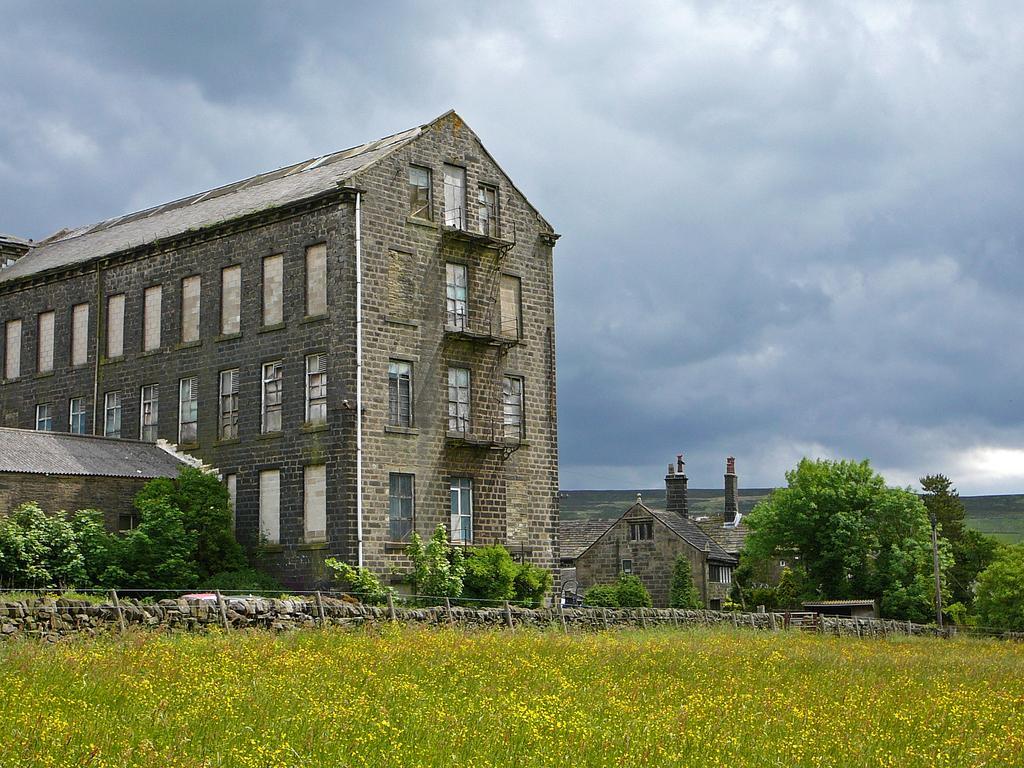In one or two sentences, can you explain what this image depicts? In this picture we can see the buildings and church. In the bottom we can see farmland, beside that there is a fencing near to the wall. At the top we can see sky and clouds. On the right we can see the mountain. 